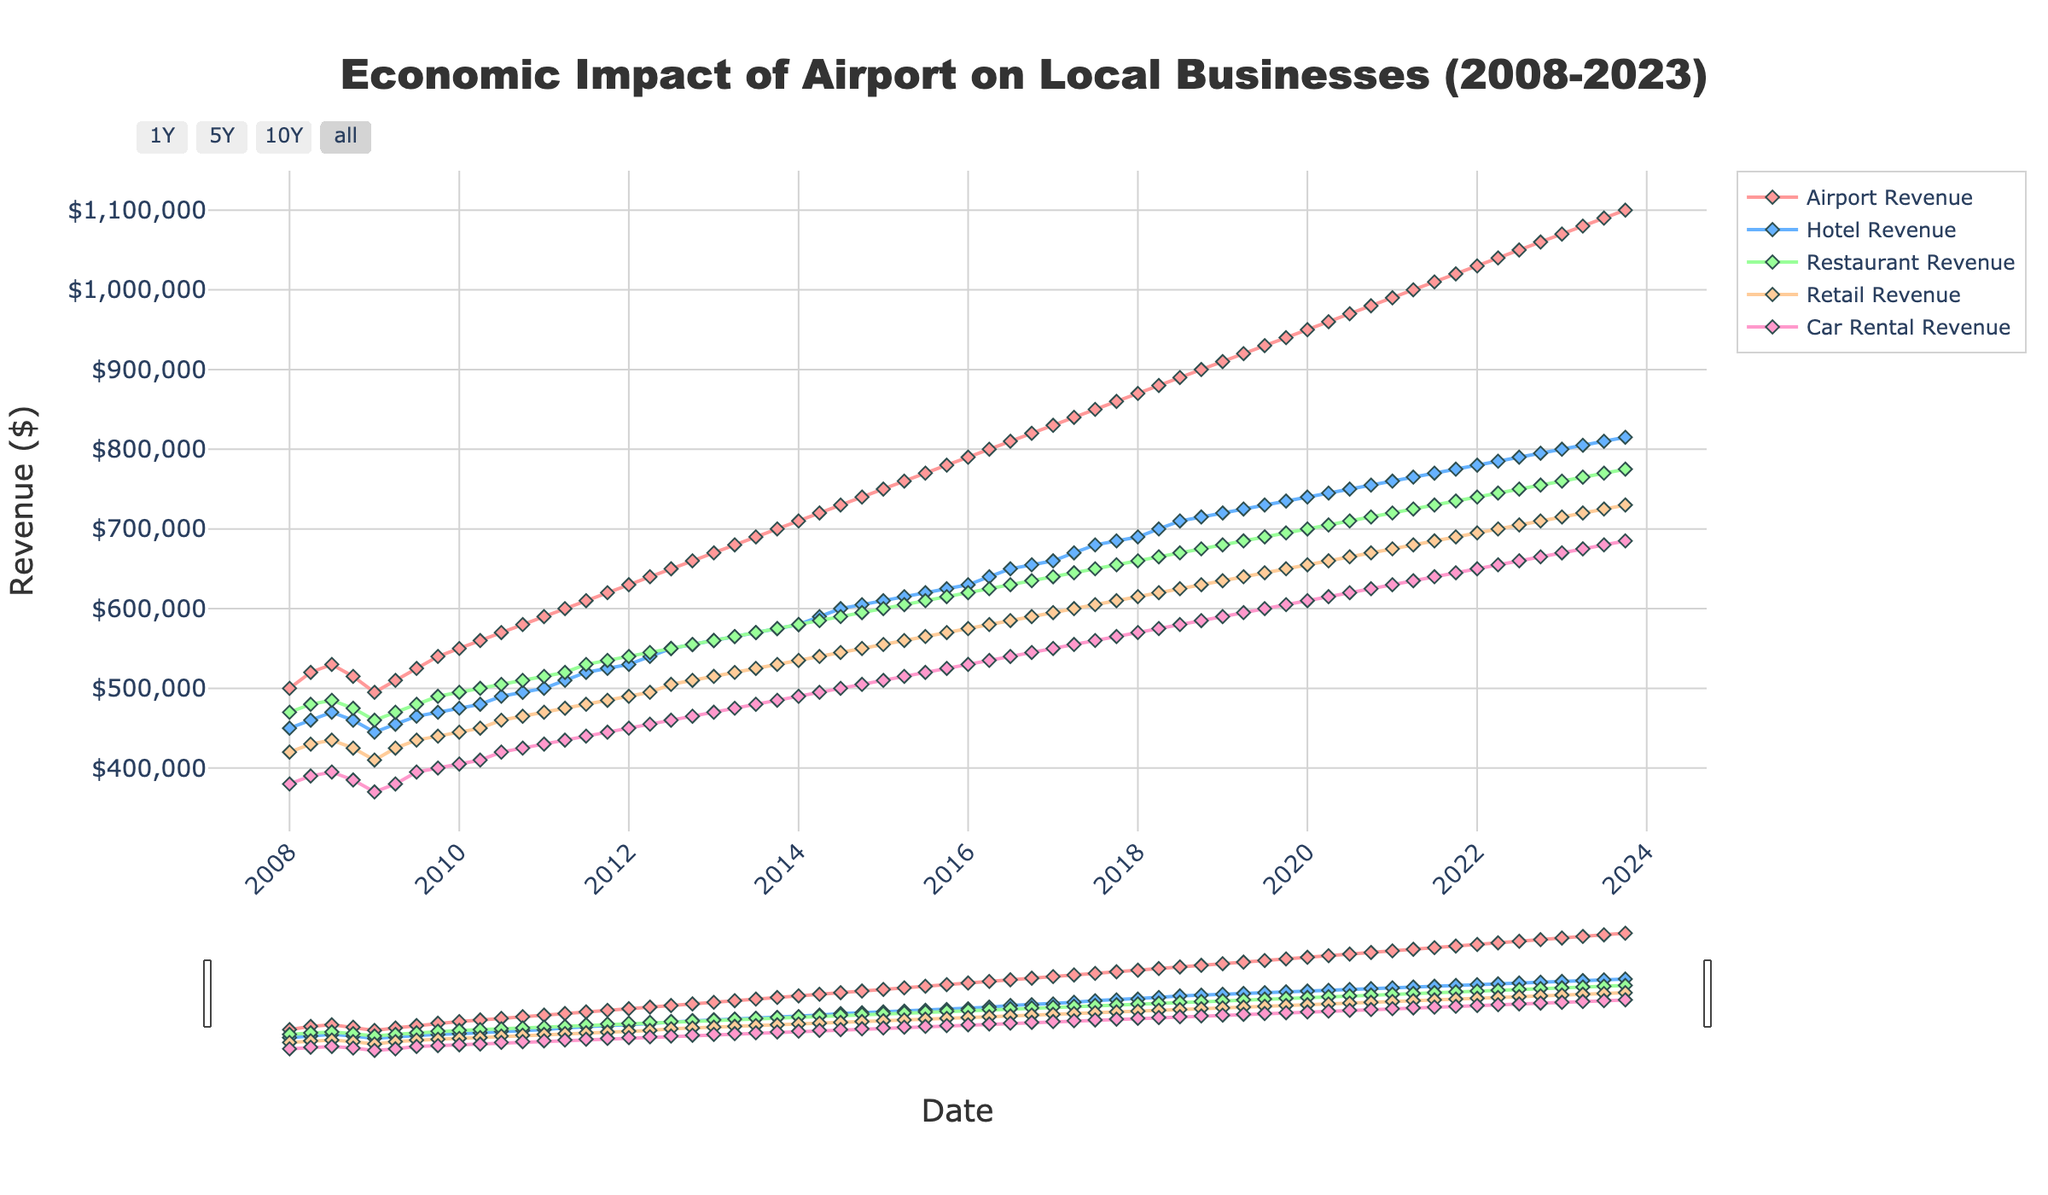What is the title of the figure? The title is at the top of the figure and reads "Economic Impact of Airport on Local Businesses (2008-2023)."
Answer: Economic Impact of Airport on Local Businesses (2008-2023) What color is used to represent Hotel Revenue in the figure? The legend for the figure shows the color associated with each revenue type. Hotel Revenue is represented by the second color in the list, which is blue.
Answer: Blue During which quarter and year did Airport Revenue first reach 1,000,000 dollars? The Airport Revenue trace can be followed in the plot until it reaches 1,000,000 dollars. This occurs in 2021-Q2.
Answer: 2021-Q2 What is the trend of Restaurant Revenue from 2008 to 2023? The Restaurant Revenue can be followed as it generally trends upwards from around 470,000 dollars in 2008 to 775,000 dollars in 2023.
Answer: Upwards Which quarter and year marked the lowest point for Car Rental Revenue, and what was the value? The lowest point for Car Rental Revenue is identified by looking at the minimum on its corresponding line in the plot. This occurred at 2008-Q1 with a value of 380,000 dollars.
Answer: 2008-Q1, 380,000 dollars What is the average Hotel Revenue between 2010-Q1 and 2015-Q4? Find the Hotel Revenue values between 2010-Q1 and 2015-Q4, sum them up, and divide by the number of quarters (6 years multiplied by 4 quarters each gives 24 quarters). Sum: 475,000 + 480,000 + ... + 625,000 = 13,950,000, and dividing by 24 quarters gives an average of 581,250 dollars.
Answer: 581,250 dollars How does Retail Revenue at the end of 2019 compare to the beginning of 2010? Compare Retail Revenue values for 2010-Q1 (445,000 dollars) and 2019-Q4 (650,000 dollars). The revenue has increased by 205,000 dollars.
Answer: Increased by 205,000 dollars What observation can be made about the economic impact of the 2008 financial crisis on Airport Revenue? The plot shows a slight dip in Airport Revenue around 2009, which suggests a minor negative impact of the financial crisis on Airport Revenue.
Answer: Slight dip in 2009 In which quarter did Hotel Revenue first exceed 700,000 dollars? Follow the Hotel Revenue line and observe when it first crosses 700,000 dollars. This occurs in 2018-Q2.
Answer: 2018-Q2 What's the difference between the highest Retail Revenue and the lowest Retail Revenue observed in the figure? The highest Retail Revenue observed is at 2023-Q4 with 730,000 dollars, and the lowest is at 2008-Q1 with 420,000 dollars. The difference is 310,000 dollars.
Answer: 310,000 dollars 